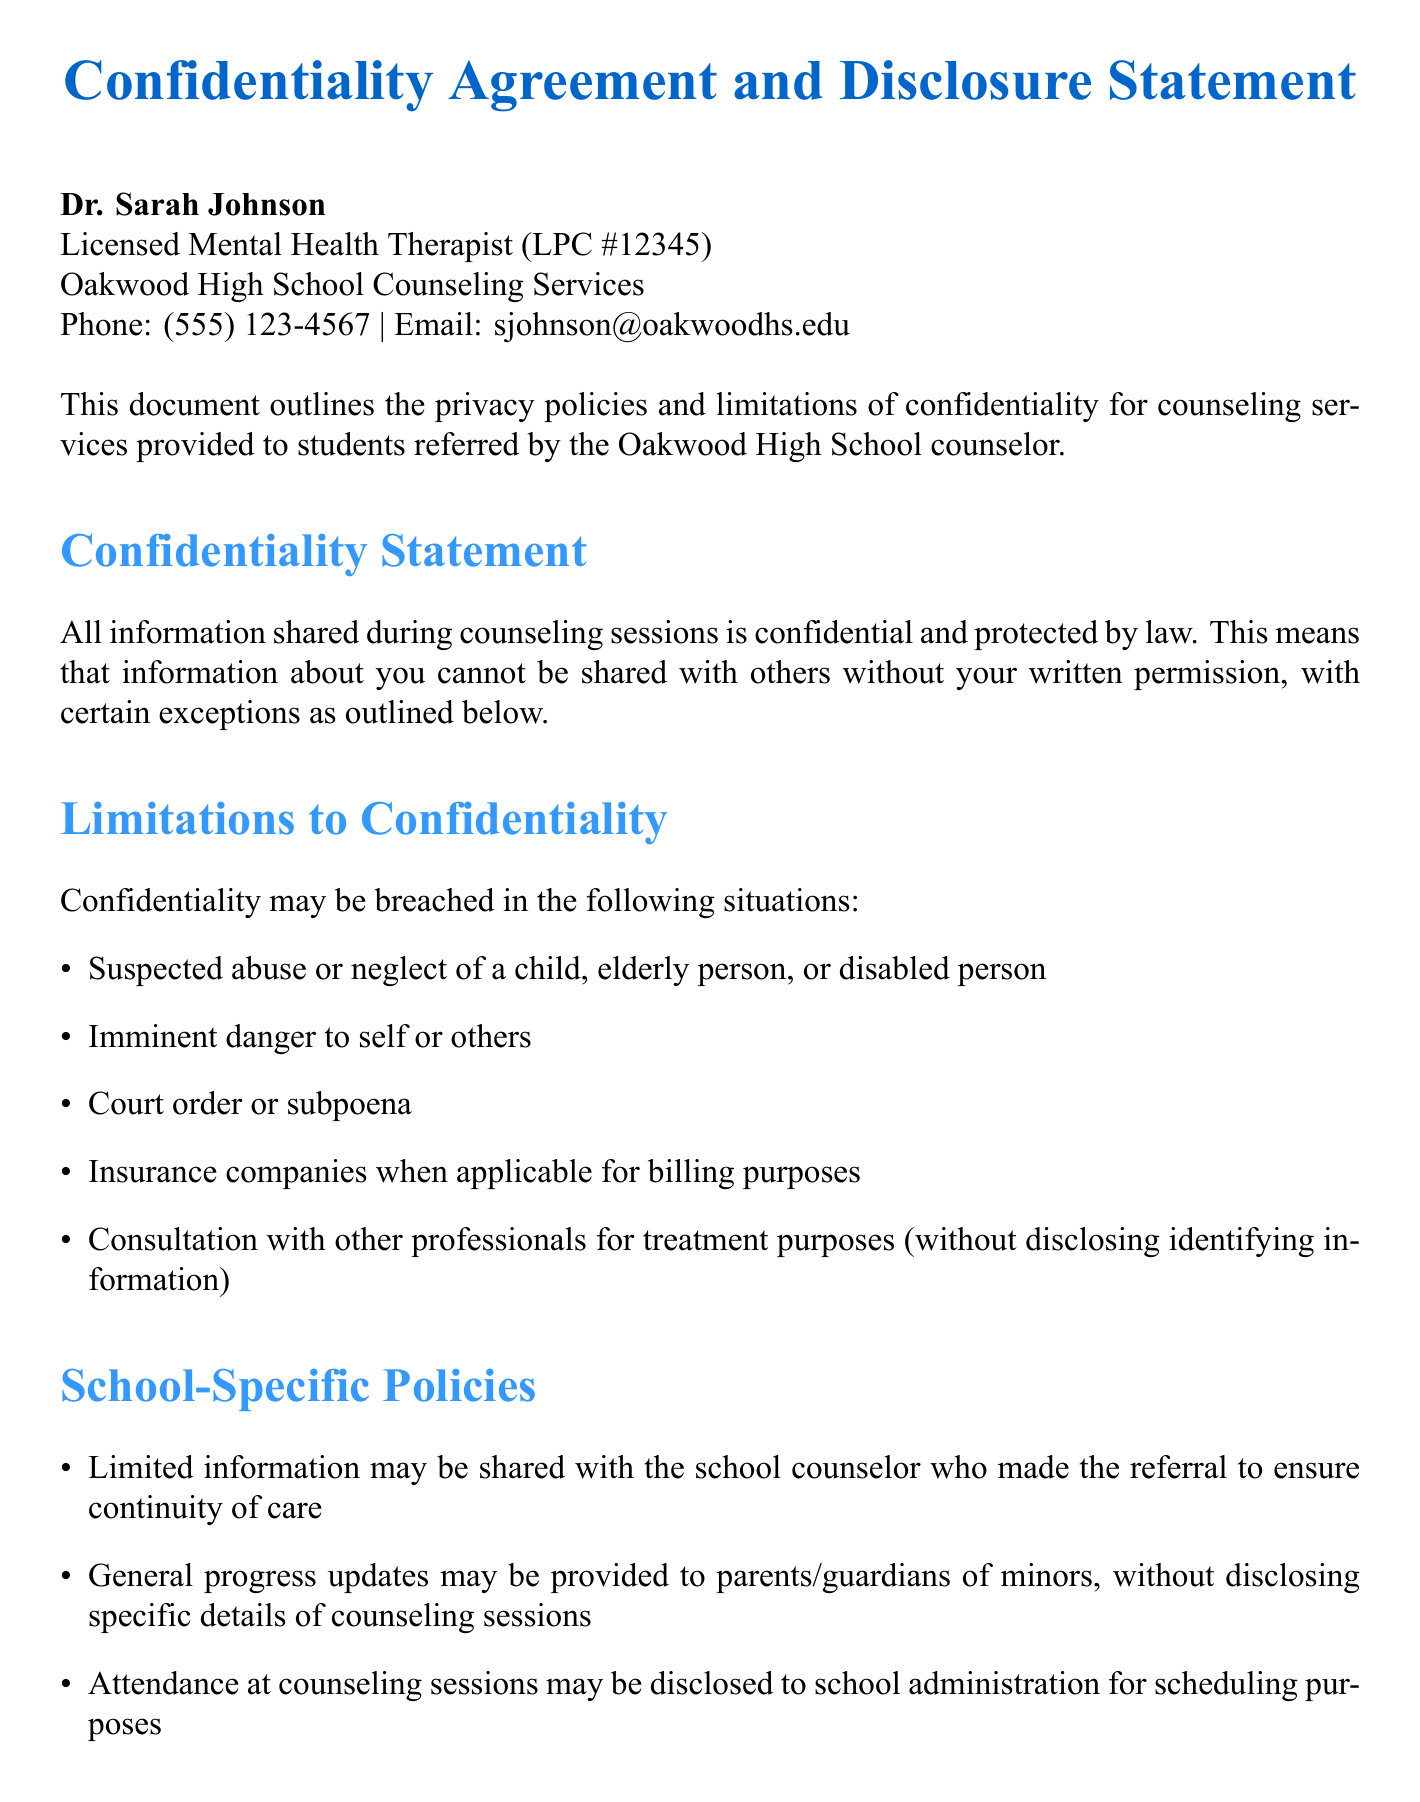What is the name of the therapist? The therapist's name is found at the beginning of the document.
Answer: Dr. Sarah Johnson What is the license number of the therapist? The license number is stated in the therapist information section.
Answer: LPC #12345 How long are records retained after the student's 18th birthday? The retention period for records is mentioned in the record-keeping section.
Answer: 7 years What phone number can be contacted for Dr. Sarah Johnson? The contact phone number for the therapist is listed in the header.
Answer: (555) 123-4567 What are the two limitations to confidentiality related to emergency situations? The limitations are explained in the confidentiality limitations section.
Answer: Suspected abuse or neglect, Imminent danger to self or others What must be done in case of a mental health emergency outside of regular hours? Emergency procedures are detailed in the emergency situations section.
Answer: Call 911 What might be shared with parents/guardians? The specific information regarding communication with parents/guardians is found in the school-specific policies section.
Answer: General progress updates What type of communication should be limited to scheduling matters only? The document discusses this in the electronic communication section.
Answer: Email and text messaging 